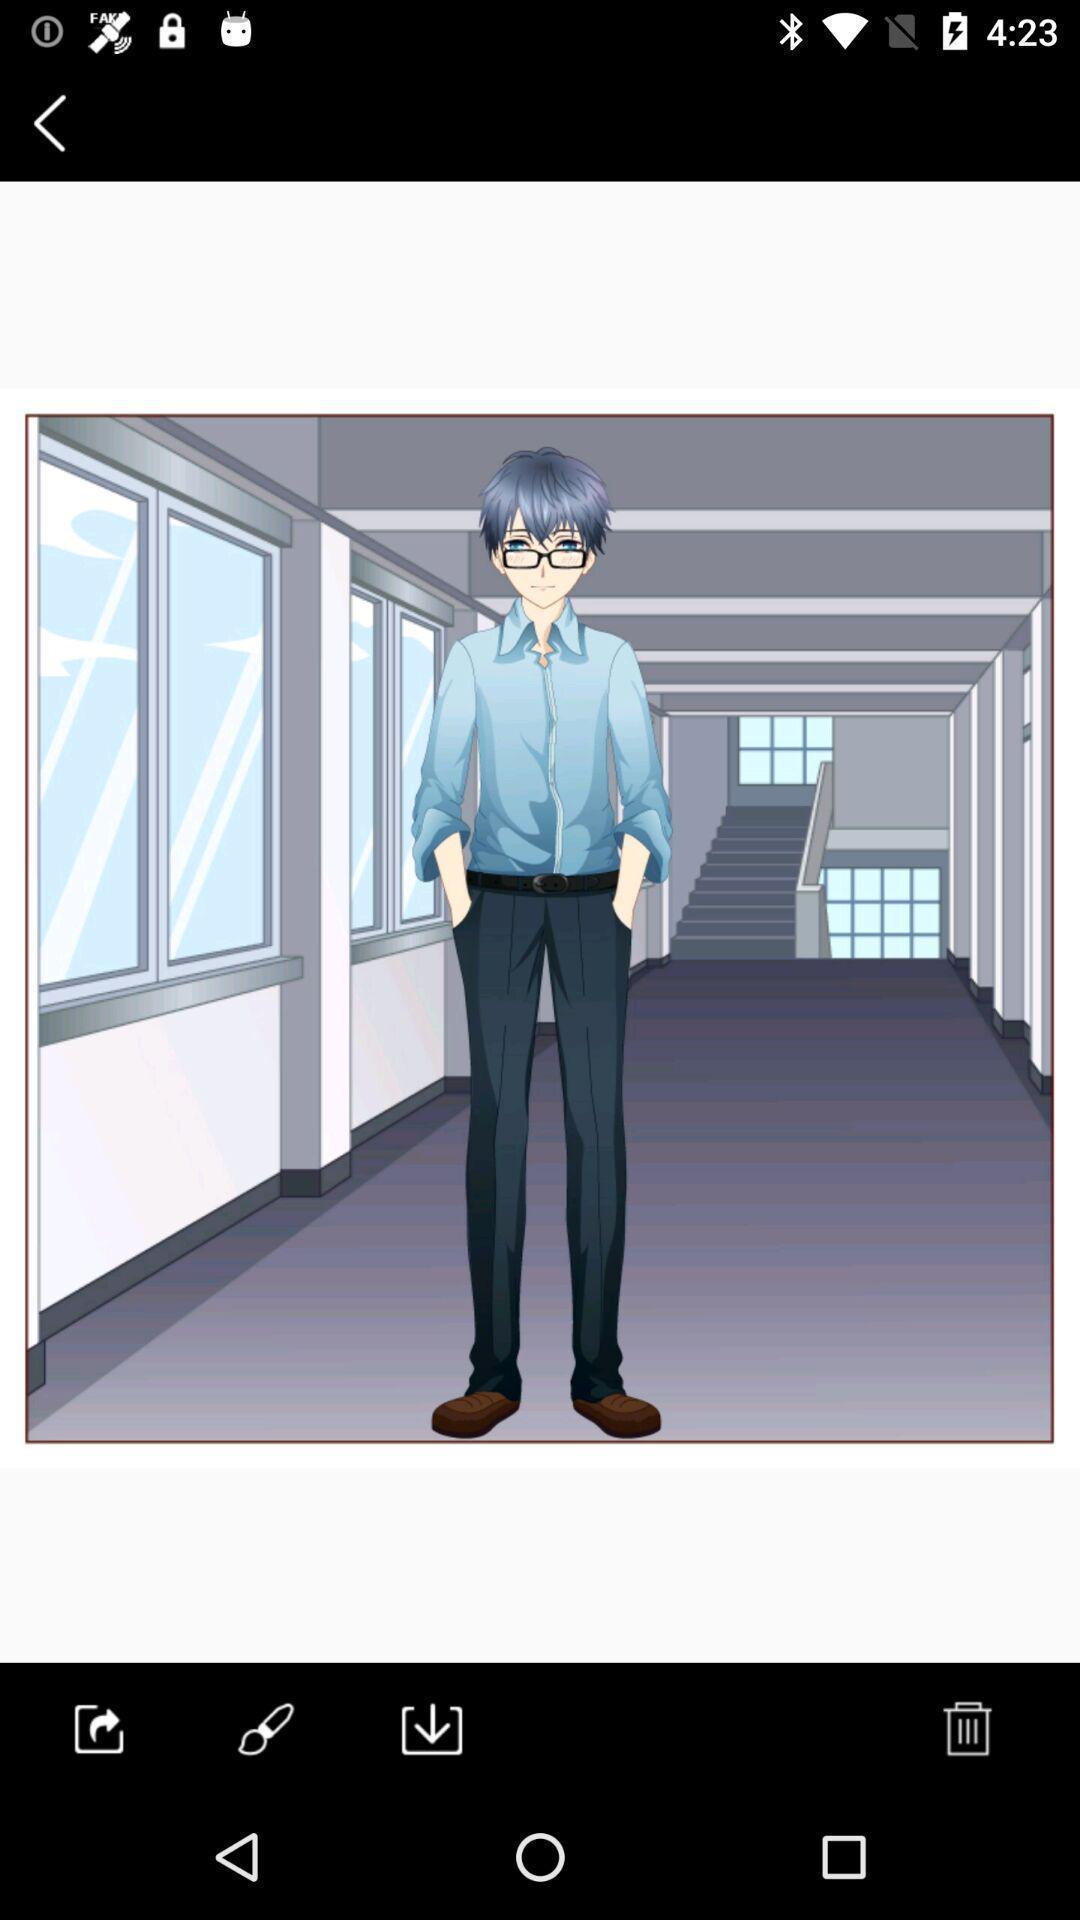Describe the visual elements of this screenshot. Window displaying a image of a person. 